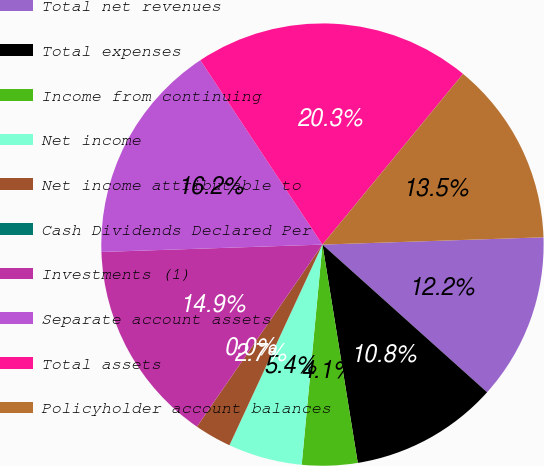<chart> <loc_0><loc_0><loc_500><loc_500><pie_chart><fcel>Total net revenues<fcel>Total expenses<fcel>Income from continuing<fcel>Net income<fcel>Net income attributable to<fcel>Cash Dividends Declared Per<fcel>Investments (1)<fcel>Separate account assets<fcel>Total assets<fcel>Policyholder account balances<nl><fcel>12.16%<fcel>10.81%<fcel>4.05%<fcel>5.41%<fcel>2.7%<fcel>0.0%<fcel>14.86%<fcel>16.22%<fcel>20.27%<fcel>13.51%<nl></chart> 